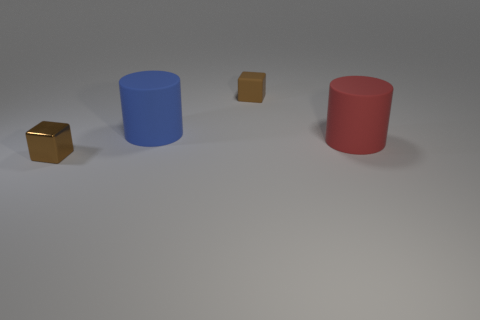Is the number of large blue cylinders to the left of the metallic object the same as the number of rubber things that are in front of the brown rubber cube?
Offer a terse response. No. What shape is the matte thing that is the same size as the red rubber cylinder?
Provide a succinct answer. Cylinder. Is there a small matte object of the same color as the tiny metallic cube?
Your response must be concise. Yes. There is a tiny object in front of the red rubber object; what shape is it?
Ensure brevity in your answer.  Cube. What color is the tiny metallic block?
Ensure brevity in your answer.  Brown. There is a block that is made of the same material as the blue thing; what is its color?
Ensure brevity in your answer.  Brown. How many things are the same material as the red cylinder?
Provide a short and direct response. 2. What number of brown cubes are behind the blue rubber cylinder?
Your response must be concise. 1. Are the brown object that is behind the red matte object and the red thing that is right of the brown metal block made of the same material?
Offer a terse response. Yes. Is the number of large rubber objects on the right side of the big blue object greater than the number of tiny brown shiny blocks that are in front of the tiny brown metallic object?
Provide a short and direct response. Yes. 